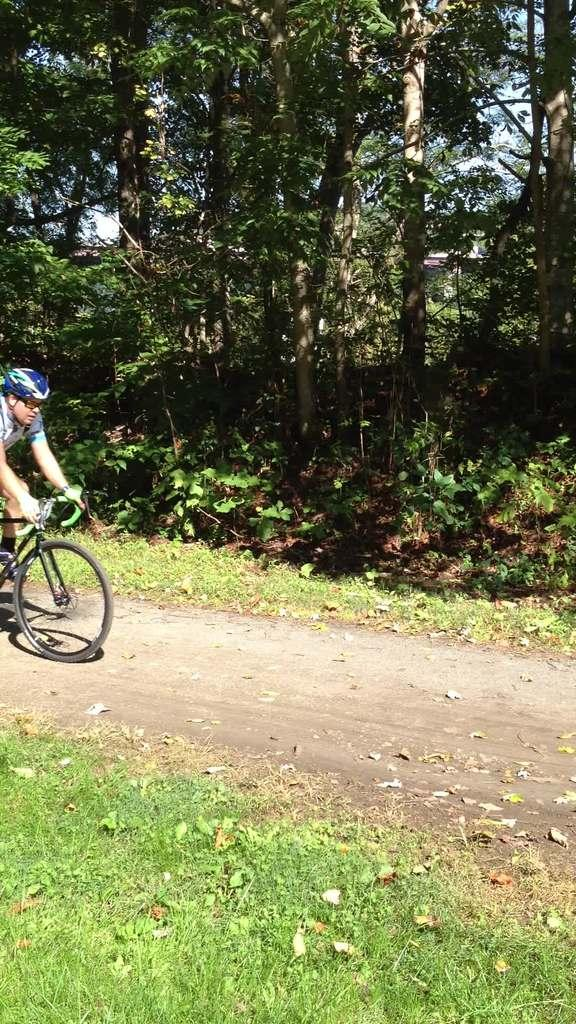What is the person in the image doing? There is a person riding a cycle in the image. What type of terrain can be seen in the image? There is grass and sand in the image. What type of vegetation is present in the image? There are trees in the image. What is visible in the background of the image? There is a sky visible in the image. What type of feather can be seen on the fan in the image? There is no fan or feather present in the image. 